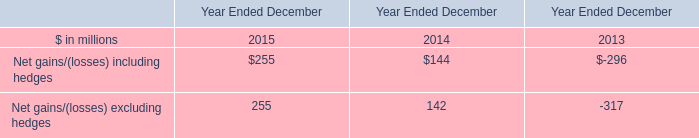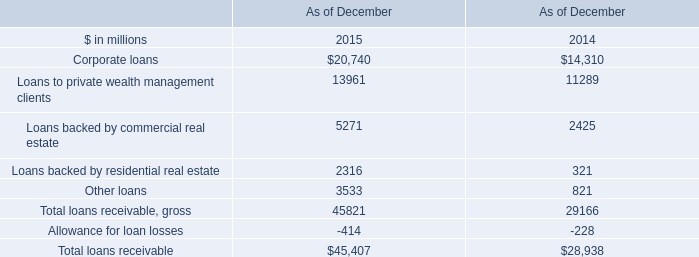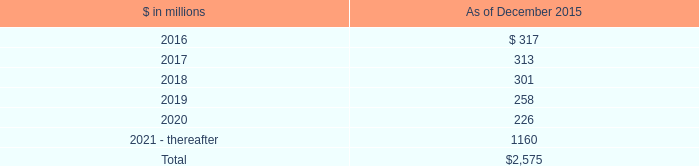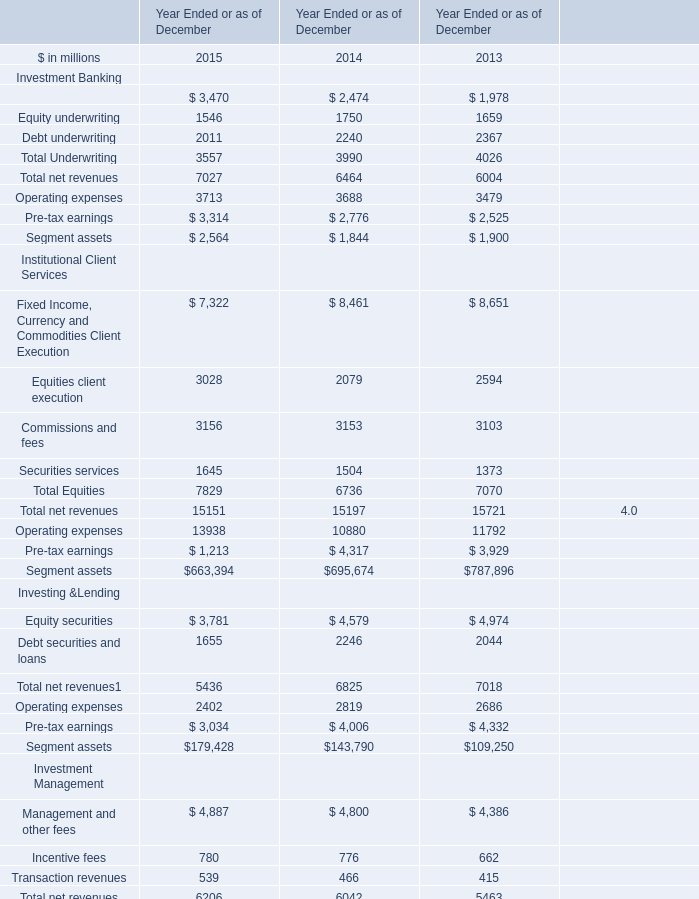in billions , what was the total for 2015 and 2014 relating to commitments to invest in funds managed by the firm? 
Computations: (2.86 + 2.87)
Answer: 5.73. 